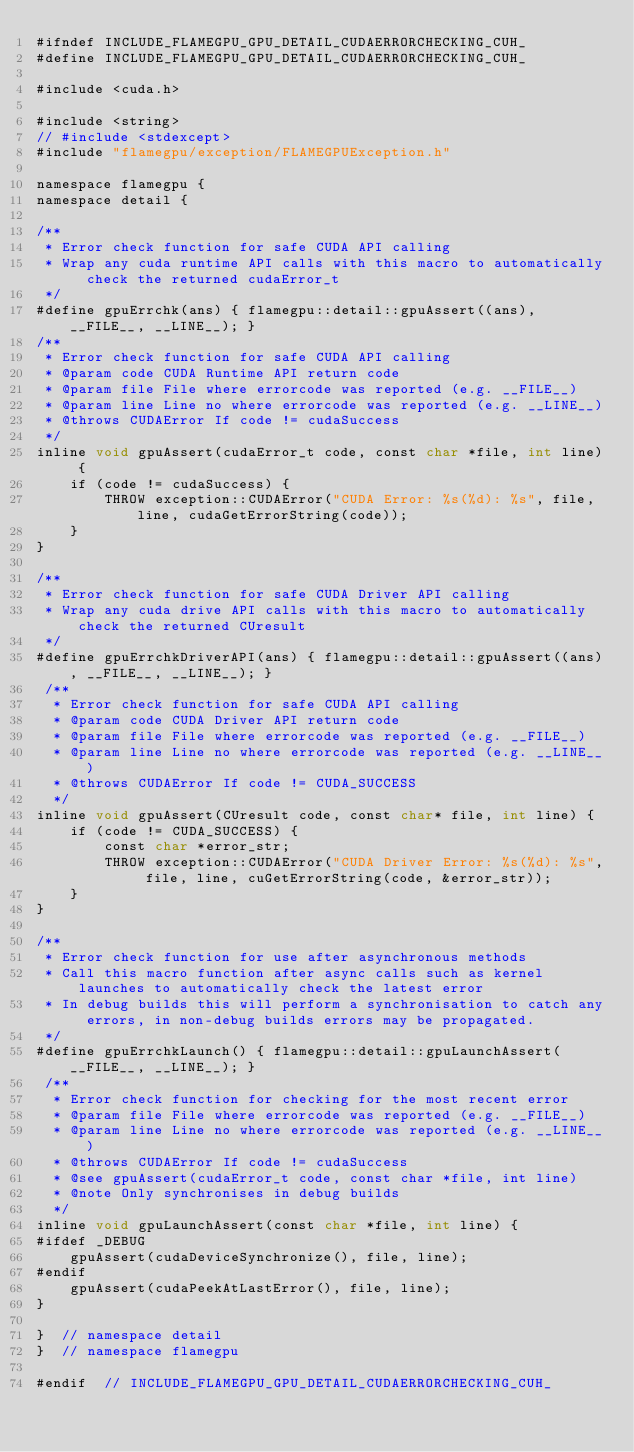Convert code to text. <code><loc_0><loc_0><loc_500><loc_500><_Cuda_>#ifndef INCLUDE_FLAMEGPU_GPU_DETAIL_CUDAERRORCHECKING_CUH_
#define INCLUDE_FLAMEGPU_GPU_DETAIL_CUDAERRORCHECKING_CUH_

#include <cuda.h>

#include <string>
// #include <stdexcept>
#include "flamegpu/exception/FLAMEGPUException.h"

namespace flamegpu {
namespace detail {

/**
 * Error check function for safe CUDA API calling
 * Wrap any cuda runtime API calls with this macro to automatically check the returned cudaError_t
 */
#define gpuErrchk(ans) { flamegpu::detail::gpuAssert((ans), __FILE__, __LINE__); }
/**
 * Error check function for safe CUDA API calling
 * @param code CUDA Runtime API return code
 * @param file File where errorcode was reported (e.g. __FILE__)
 * @param line Line no where errorcode was reported (e.g. __LINE__)
 * @throws CUDAError If code != cudaSuccess
 */
inline void gpuAssert(cudaError_t code, const char *file, int line) {
    if (code != cudaSuccess) {
        THROW exception::CUDAError("CUDA Error: %s(%d): %s", file, line, cudaGetErrorString(code));
    }
}

/**
 * Error check function for safe CUDA Driver API calling
 * Wrap any cuda drive API calls with this macro to automatically check the returned CUresult
 */
#define gpuErrchkDriverAPI(ans) { flamegpu::detail::gpuAssert((ans), __FILE__, __LINE__); }
 /**
  * Error check function for safe CUDA API calling
  * @param code CUDA Driver API return code
  * @param file File where errorcode was reported (e.g. __FILE__)
  * @param line Line no where errorcode was reported (e.g. __LINE__)
  * @throws CUDAError If code != CUDA_SUCCESS
  */
inline void gpuAssert(CUresult code, const char* file, int line) {
    if (code != CUDA_SUCCESS) {
        const char *error_str;
        THROW exception::CUDAError("CUDA Driver Error: %s(%d): %s", file, line, cuGetErrorString(code, &error_str));
    }
}

/**
 * Error check function for use after asynchronous methods
 * Call this macro function after async calls such as kernel launches to automatically check the latest error
 * In debug builds this will perform a synchronisation to catch any errors, in non-debug builds errors may be propagated.
 */
#define gpuErrchkLaunch() { flamegpu::detail::gpuLaunchAssert(__FILE__, __LINE__); }
 /**
  * Error check function for checking for the most recent error
  * @param file File where errorcode was reported (e.g. __FILE__)
  * @param line Line no where errorcode was reported (e.g. __LINE__)
  * @throws CUDAError If code != cudaSuccess
  * @see gpuAssert(cudaError_t code, const char *file, int line)
  * @note Only synchronises in debug builds
  */
inline void gpuLaunchAssert(const char *file, int line) {
#ifdef _DEBUG
    gpuAssert(cudaDeviceSynchronize(), file, line);
#endif
    gpuAssert(cudaPeekAtLastError(), file, line);
}

}  // namespace detail
}  // namespace flamegpu

#endif  // INCLUDE_FLAMEGPU_GPU_DETAIL_CUDAERRORCHECKING_CUH_
</code> 